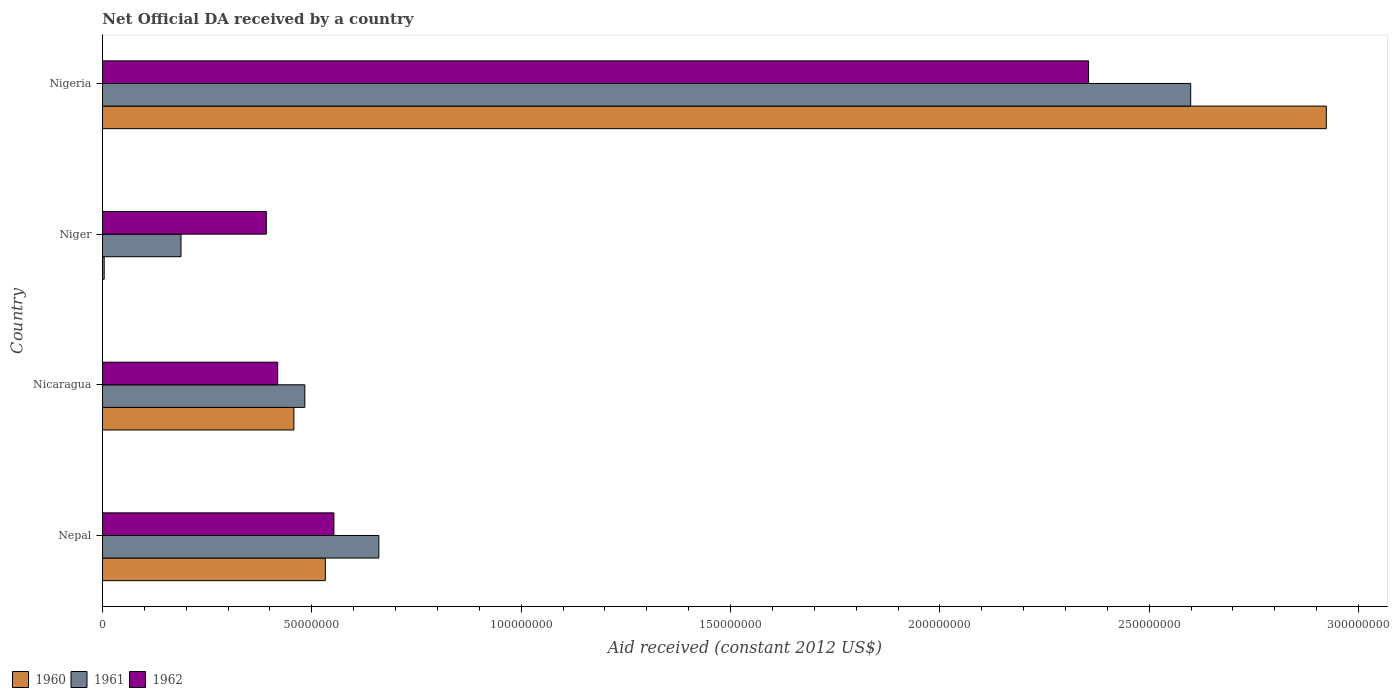Are the number of bars per tick equal to the number of legend labels?
Keep it short and to the point. Yes. Are the number of bars on each tick of the Y-axis equal?
Your response must be concise. Yes. How many bars are there on the 1st tick from the top?
Keep it short and to the point. 3. How many bars are there on the 4th tick from the bottom?
Your answer should be compact. 3. What is the label of the 1st group of bars from the top?
Make the answer very short. Nigeria. What is the net official development assistance aid received in 1961 in Nigeria?
Offer a very short reply. 2.60e+08. Across all countries, what is the maximum net official development assistance aid received in 1961?
Offer a terse response. 2.60e+08. In which country was the net official development assistance aid received in 1961 maximum?
Ensure brevity in your answer.  Nigeria. In which country was the net official development assistance aid received in 1961 minimum?
Give a very brief answer. Niger. What is the total net official development assistance aid received in 1961 in the graph?
Make the answer very short. 3.93e+08. What is the difference between the net official development assistance aid received in 1960 in Nepal and that in Nigeria?
Your response must be concise. -2.39e+08. What is the difference between the net official development assistance aid received in 1962 in Nepal and the net official development assistance aid received in 1961 in Niger?
Provide a short and direct response. 3.65e+07. What is the average net official development assistance aid received in 1961 per country?
Make the answer very short. 9.82e+07. What is the difference between the net official development assistance aid received in 1960 and net official development assistance aid received in 1961 in Niger?
Offer a terse response. -1.84e+07. In how many countries, is the net official development assistance aid received in 1962 greater than 30000000 US$?
Ensure brevity in your answer.  4. What is the ratio of the net official development assistance aid received in 1962 in Nicaragua to that in Niger?
Your response must be concise. 1.07. What is the difference between the highest and the second highest net official development assistance aid received in 1962?
Provide a short and direct response. 1.80e+08. What is the difference between the highest and the lowest net official development assistance aid received in 1962?
Keep it short and to the point. 1.96e+08. In how many countries, is the net official development assistance aid received in 1961 greater than the average net official development assistance aid received in 1961 taken over all countries?
Provide a short and direct response. 1. Does the graph contain any zero values?
Provide a succinct answer. No. Where does the legend appear in the graph?
Your answer should be compact. Bottom left. What is the title of the graph?
Offer a very short reply. Net Official DA received by a country. Does "1964" appear as one of the legend labels in the graph?
Offer a very short reply. No. What is the label or title of the X-axis?
Offer a terse response. Aid received (constant 2012 US$). What is the label or title of the Y-axis?
Make the answer very short. Country. What is the Aid received (constant 2012 US$) in 1960 in Nepal?
Ensure brevity in your answer.  5.32e+07. What is the Aid received (constant 2012 US$) in 1961 in Nepal?
Offer a terse response. 6.60e+07. What is the Aid received (constant 2012 US$) in 1962 in Nepal?
Give a very brief answer. 5.53e+07. What is the Aid received (constant 2012 US$) in 1960 in Nicaragua?
Your response must be concise. 4.57e+07. What is the Aid received (constant 2012 US$) of 1961 in Nicaragua?
Provide a short and direct response. 4.83e+07. What is the Aid received (constant 2012 US$) in 1962 in Nicaragua?
Your answer should be very brief. 4.18e+07. What is the Aid received (constant 2012 US$) in 1961 in Niger?
Offer a terse response. 1.88e+07. What is the Aid received (constant 2012 US$) in 1962 in Niger?
Offer a very short reply. 3.91e+07. What is the Aid received (constant 2012 US$) of 1960 in Nigeria?
Your answer should be very brief. 2.92e+08. What is the Aid received (constant 2012 US$) of 1961 in Nigeria?
Ensure brevity in your answer.  2.60e+08. What is the Aid received (constant 2012 US$) of 1962 in Nigeria?
Provide a short and direct response. 2.36e+08. Across all countries, what is the maximum Aid received (constant 2012 US$) of 1960?
Give a very brief answer. 2.92e+08. Across all countries, what is the maximum Aid received (constant 2012 US$) in 1961?
Offer a terse response. 2.60e+08. Across all countries, what is the maximum Aid received (constant 2012 US$) in 1962?
Keep it short and to the point. 2.36e+08. Across all countries, what is the minimum Aid received (constant 2012 US$) of 1960?
Your answer should be very brief. 4.10e+05. Across all countries, what is the minimum Aid received (constant 2012 US$) of 1961?
Offer a very short reply. 1.88e+07. Across all countries, what is the minimum Aid received (constant 2012 US$) of 1962?
Your answer should be compact. 3.91e+07. What is the total Aid received (constant 2012 US$) in 1960 in the graph?
Your answer should be very brief. 3.92e+08. What is the total Aid received (constant 2012 US$) in 1961 in the graph?
Provide a succinct answer. 3.93e+08. What is the total Aid received (constant 2012 US$) in 1962 in the graph?
Offer a terse response. 3.72e+08. What is the difference between the Aid received (constant 2012 US$) of 1960 in Nepal and that in Nicaragua?
Make the answer very short. 7.52e+06. What is the difference between the Aid received (constant 2012 US$) in 1961 in Nepal and that in Nicaragua?
Your answer should be very brief. 1.77e+07. What is the difference between the Aid received (constant 2012 US$) in 1962 in Nepal and that in Nicaragua?
Make the answer very short. 1.34e+07. What is the difference between the Aid received (constant 2012 US$) of 1960 in Nepal and that in Niger?
Your response must be concise. 5.28e+07. What is the difference between the Aid received (constant 2012 US$) of 1961 in Nepal and that in Niger?
Offer a very short reply. 4.72e+07. What is the difference between the Aid received (constant 2012 US$) in 1962 in Nepal and that in Niger?
Offer a terse response. 1.62e+07. What is the difference between the Aid received (constant 2012 US$) in 1960 in Nepal and that in Nigeria?
Ensure brevity in your answer.  -2.39e+08. What is the difference between the Aid received (constant 2012 US$) of 1961 in Nepal and that in Nigeria?
Ensure brevity in your answer.  -1.94e+08. What is the difference between the Aid received (constant 2012 US$) of 1962 in Nepal and that in Nigeria?
Offer a terse response. -1.80e+08. What is the difference between the Aid received (constant 2012 US$) of 1960 in Nicaragua and that in Niger?
Provide a short and direct response. 4.53e+07. What is the difference between the Aid received (constant 2012 US$) of 1961 in Nicaragua and that in Niger?
Make the answer very short. 2.96e+07. What is the difference between the Aid received (constant 2012 US$) in 1962 in Nicaragua and that in Niger?
Keep it short and to the point. 2.72e+06. What is the difference between the Aid received (constant 2012 US$) of 1960 in Nicaragua and that in Nigeria?
Give a very brief answer. -2.47e+08. What is the difference between the Aid received (constant 2012 US$) of 1961 in Nicaragua and that in Nigeria?
Keep it short and to the point. -2.12e+08. What is the difference between the Aid received (constant 2012 US$) of 1962 in Nicaragua and that in Nigeria?
Provide a short and direct response. -1.94e+08. What is the difference between the Aid received (constant 2012 US$) in 1960 in Niger and that in Nigeria?
Give a very brief answer. -2.92e+08. What is the difference between the Aid received (constant 2012 US$) in 1961 in Niger and that in Nigeria?
Offer a terse response. -2.41e+08. What is the difference between the Aid received (constant 2012 US$) in 1962 in Niger and that in Nigeria?
Ensure brevity in your answer.  -1.96e+08. What is the difference between the Aid received (constant 2012 US$) in 1960 in Nepal and the Aid received (constant 2012 US$) in 1961 in Nicaragua?
Ensure brevity in your answer.  4.90e+06. What is the difference between the Aid received (constant 2012 US$) in 1960 in Nepal and the Aid received (constant 2012 US$) in 1962 in Nicaragua?
Offer a terse response. 1.14e+07. What is the difference between the Aid received (constant 2012 US$) in 1961 in Nepal and the Aid received (constant 2012 US$) in 1962 in Nicaragua?
Provide a short and direct response. 2.42e+07. What is the difference between the Aid received (constant 2012 US$) of 1960 in Nepal and the Aid received (constant 2012 US$) of 1961 in Niger?
Keep it short and to the point. 3.45e+07. What is the difference between the Aid received (constant 2012 US$) in 1960 in Nepal and the Aid received (constant 2012 US$) in 1962 in Niger?
Your response must be concise. 1.41e+07. What is the difference between the Aid received (constant 2012 US$) in 1961 in Nepal and the Aid received (constant 2012 US$) in 1962 in Niger?
Give a very brief answer. 2.69e+07. What is the difference between the Aid received (constant 2012 US$) in 1960 in Nepal and the Aid received (constant 2012 US$) in 1961 in Nigeria?
Keep it short and to the point. -2.07e+08. What is the difference between the Aid received (constant 2012 US$) in 1960 in Nepal and the Aid received (constant 2012 US$) in 1962 in Nigeria?
Make the answer very short. -1.82e+08. What is the difference between the Aid received (constant 2012 US$) of 1961 in Nepal and the Aid received (constant 2012 US$) of 1962 in Nigeria?
Your answer should be very brief. -1.70e+08. What is the difference between the Aid received (constant 2012 US$) in 1960 in Nicaragua and the Aid received (constant 2012 US$) in 1961 in Niger?
Your answer should be compact. 2.70e+07. What is the difference between the Aid received (constant 2012 US$) of 1960 in Nicaragua and the Aid received (constant 2012 US$) of 1962 in Niger?
Keep it short and to the point. 6.58e+06. What is the difference between the Aid received (constant 2012 US$) in 1961 in Nicaragua and the Aid received (constant 2012 US$) in 1962 in Niger?
Keep it short and to the point. 9.20e+06. What is the difference between the Aid received (constant 2012 US$) of 1960 in Nicaragua and the Aid received (constant 2012 US$) of 1961 in Nigeria?
Provide a short and direct response. -2.14e+08. What is the difference between the Aid received (constant 2012 US$) of 1960 in Nicaragua and the Aid received (constant 2012 US$) of 1962 in Nigeria?
Offer a terse response. -1.90e+08. What is the difference between the Aid received (constant 2012 US$) in 1961 in Nicaragua and the Aid received (constant 2012 US$) in 1962 in Nigeria?
Make the answer very short. -1.87e+08. What is the difference between the Aid received (constant 2012 US$) of 1960 in Niger and the Aid received (constant 2012 US$) of 1961 in Nigeria?
Provide a succinct answer. -2.59e+08. What is the difference between the Aid received (constant 2012 US$) in 1960 in Niger and the Aid received (constant 2012 US$) in 1962 in Nigeria?
Provide a short and direct response. -2.35e+08. What is the difference between the Aid received (constant 2012 US$) of 1961 in Niger and the Aid received (constant 2012 US$) of 1962 in Nigeria?
Your answer should be very brief. -2.17e+08. What is the average Aid received (constant 2012 US$) of 1960 per country?
Keep it short and to the point. 9.79e+07. What is the average Aid received (constant 2012 US$) of 1961 per country?
Provide a short and direct response. 9.82e+07. What is the average Aid received (constant 2012 US$) of 1962 per country?
Your response must be concise. 9.29e+07. What is the difference between the Aid received (constant 2012 US$) of 1960 and Aid received (constant 2012 US$) of 1961 in Nepal?
Your answer should be compact. -1.28e+07. What is the difference between the Aid received (constant 2012 US$) of 1960 and Aid received (constant 2012 US$) of 1962 in Nepal?
Provide a succinct answer. -2.05e+06. What is the difference between the Aid received (constant 2012 US$) in 1961 and Aid received (constant 2012 US$) in 1962 in Nepal?
Give a very brief answer. 1.07e+07. What is the difference between the Aid received (constant 2012 US$) in 1960 and Aid received (constant 2012 US$) in 1961 in Nicaragua?
Offer a very short reply. -2.62e+06. What is the difference between the Aid received (constant 2012 US$) in 1960 and Aid received (constant 2012 US$) in 1962 in Nicaragua?
Make the answer very short. 3.86e+06. What is the difference between the Aid received (constant 2012 US$) of 1961 and Aid received (constant 2012 US$) of 1962 in Nicaragua?
Offer a very short reply. 6.48e+06. What is the difference between the Aid received (constant 2012 US$) in 1960 and Aid received (constant 2012 US$) in 1961 in Niger?
Keep it short and to the point. -1.84e+07. What is the difference between the Aid received (constant 2012 US$) in 1960 and Aid received (constant 2012 US$) in 1962 in Niger?
Give a very brief answer. -3.87e+07. What is the difference between the Aid received (constant 2012 US$) in 1961 and Aid received (constant 2012 US$) in 1962 in Niger?
Offer a terse response. -2.04e+07. What is the difference between the Aid received (constant 2012 US$) of 1960 and Aid received (constant 2012 US$) of 1961 in Nigeria?
Your answer should be compact. 3.24e+07. What is the difference between the Aid received (constant 2012 US$) of 1960 and Aid received (constant 2012 US$) of 1962 in Nigeria?
Your answer should be compact. 5.68e+07. What is the difference between the Aid received (constant 2012 US$) of 1961 and Aid received (constant 2012 US$) of 1962 in Nigeria?
Your response must be concise. 2.44e+07. What is the ratio of the Aid received (constant 2012 US$) of 1960 in Nepal to that in Nicaragua?
Provide a succinct answer. 1.16. What is the ratio of the Aid received (constant 2012 US$) in 1961 in Nepal to that in Nicaragua?
Give a very brief answer. 1.37. What is the ratio of the Aid received (constant 2012 US$) in 1962 in Nepal to that in Nicaragua?
Your response must be concise. 1.32. What is the ratio of the Aid received (constant 2012 US$) in 1960 in Nepal to that in Niger?
Ensure brevity in your answer.  129.83. What is the ratio of the Aid received (constant 2012 US$) in 1961 in Nepal to that in Niger?
Offer a very short reply. 3.52. What is the ratio of the Aid received (constant 2012 US$) of 1962 in Nepal to that in Niger?
Ensure brevity in your answer.  1.41. What is the ratio of the Aid received (constant 2012 US$) in 1960 in Nepal to that in Nigeria?
Offer a very short reply. 0.18. What is the ratio of the Aid received (constant 2012 US$) in 1961 in Nepal to that in Nigeria?
Your answer should be very brief. 0.25. What is the ratio of the Aid received (constant 2012 US$) of 1962 in Nepal to that in Nigeria?
Make the answer very short. 0.23. What is the ratio of the Aid received (constant 2012 US$) in 1960 in Nicaragua to that in Niger?
Ensure brevity in your answer.  111.49. What is the ratio of the Aid received (constant 2012 US$) in 1961 in Nicaragua to that in Niger?
Give a very brief answer. 2.58. What is the ratio of the Aid received (constant 2012 US$) of 1962 in Nicaragua to that in Niger?
Provide a short and direct response. 1.07. What is the ratio of the Aid received (constant 2012 US$) of 1960 in Nicaragua to that in Nigeria?
Keep it short and to the point. 0.16. What is the ratio of the Aid received (constant 2012 US$) of 1961 in Nicaragua to that in Nigeria?
Give a very brief answer. 0.19. What is the ratio of the Aid received (constant 2012 US$) of 1962 in Nicaragua to that in Nigeria?
Provide a short and direct response. 0.18. What is the ratio of the Aid received (constant 2012 US$) of 1960 in Niger to that in Nigeria?
Give a very brief answer. 0. What is the ratio of the Aid received (constant 2012 US$) in 1961 in Niger to that in Nigeria?
Give a very brief answer. 0.07. What is the ratio of the Aid received (constant 2012 US$) in 1962 in Niger to that in Nigeria?
Ensure brevity in your answer.  0.17. What is the difference between the highest and the second highest Aid received (constant 2012 US$) in 1960?
Provide a short and direct response. 2.39e+08. What is the difference between the highest and the second highest Aid received (constant 2012 US$) of 1961?
Your answer should be very brief. 1.94e+08. What is the difference between the highest and the second highest Aid received (constant 2012 US$) of 1962?
Ensure brevity in your answer.  1.80e+08. What is the difference between the highest and the lowest Aid received (constant 2012 US$) in 1960?
Ensure brevity in your answer.  2.92e+08. What is the difference between the highest and the lowest Aid received (constant 2012 US$) in 1961?
Provide a short and direct response. 2.41e+08. What is the difference between the highest and the lowest Aid received (constant 2012 US$) of 1962?
Make the answer very short. 1.96e+08. 